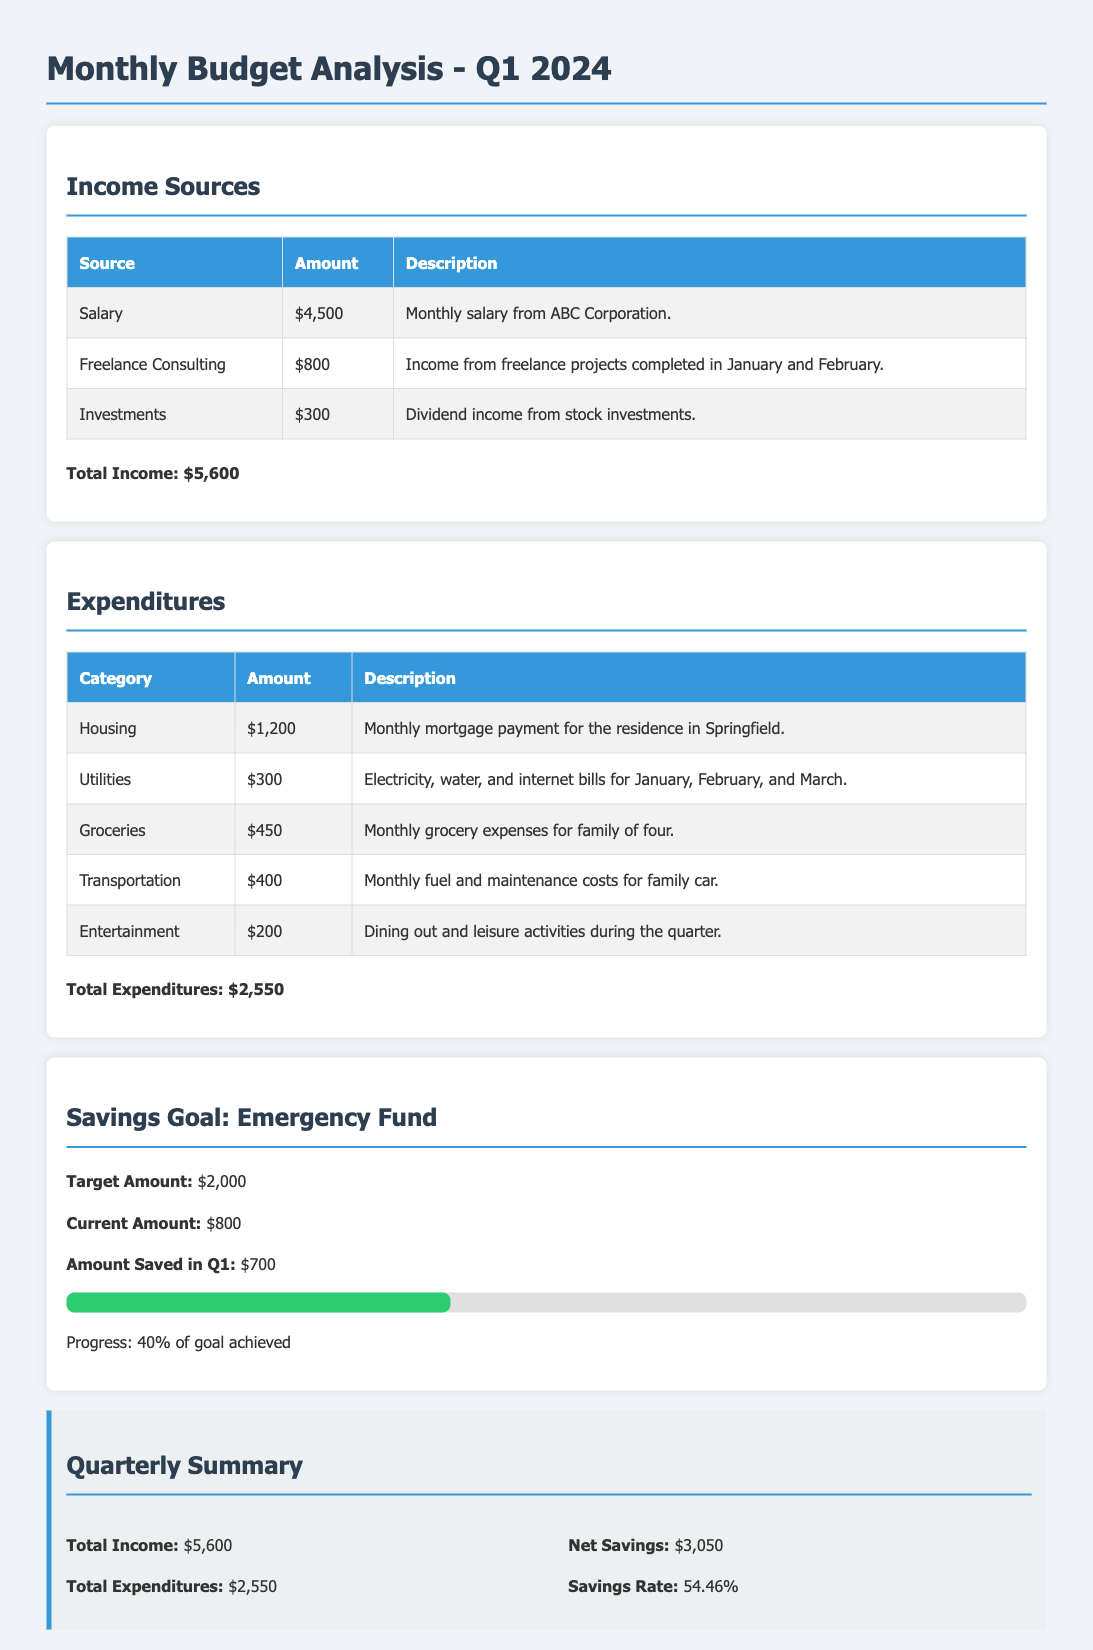What is the total income? The total income is provided at the end of the income sources section, which sums up all sources of income: salary, freelance consulting, and investments.
Answer: $5,600 What is the largest expenditure category? The expenditures table lists various categories, and the largest expenditure is the one with the highest amount shown, which is housing.
Answer: Housing How much was saved in Q1? The amount saved in Q1 is specified in the savings goal section under "Amount Saved in Q1."
Answer: $700 What is the target amount for the emergency fund? The target amount for the emergency fund is explicitly mentioned in the savings goal section.
Answer: $2,000 What is the net savings for the quarter? The net savings is calculated as total income minus total expenditures, as shown in the quarterly summary.
Answer: $3,050 What are the total expenditures? The total expenditures are provided at the end of the expenditures section, representing the sum of all listed categories.
Answer: $2,550 What is the savings rate? The savings rate is mentioned in the quarterly summary and calculated as a percentage of income saved.
Answer: 54.46% How much income was earned from freelance consulting? The income from freelance consulting is listed in the income sources table along with its amount and description.
Answer: $800 